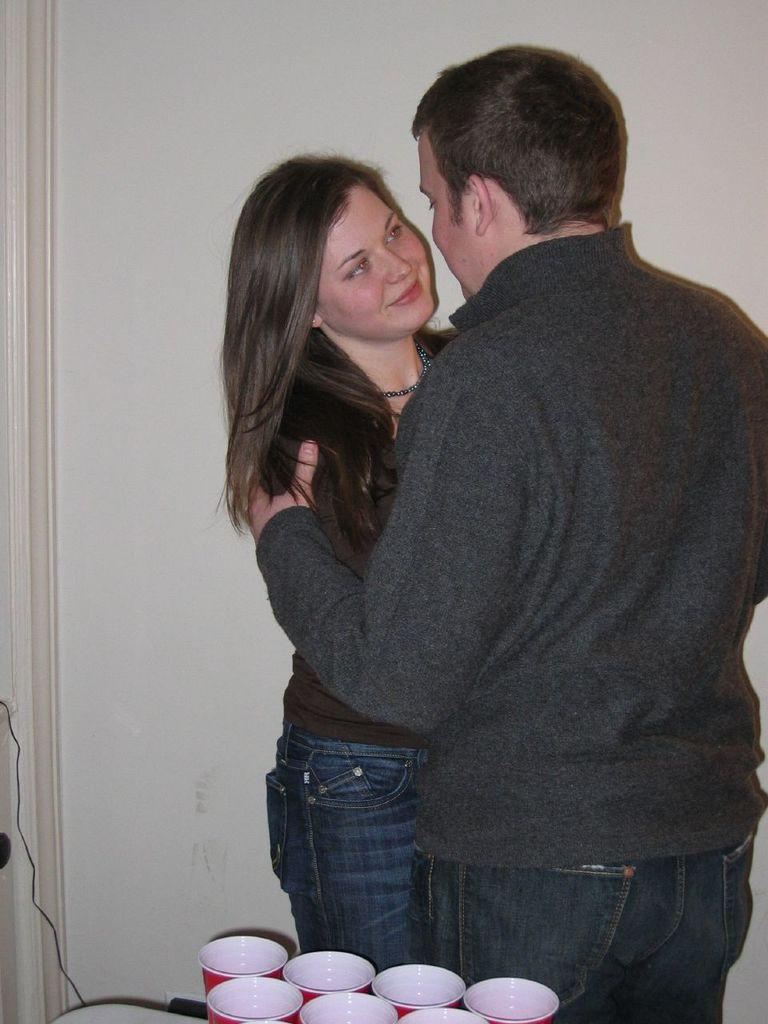What is the main subject of the image? There is a man in the image. What is the man doing in the image? The man is holding a woman. What are the man and the woman wearing? Both the man and the woman are wearing black tops. What can be seen at the bottom of the image? There are glasses at the bottom of the image. What color are the glasses? The glasses are red in color. What is visible in the background of the image? There is a wall in the background of the image. How many pizzas can be seen in the image? There are no pizzas present in the image. 